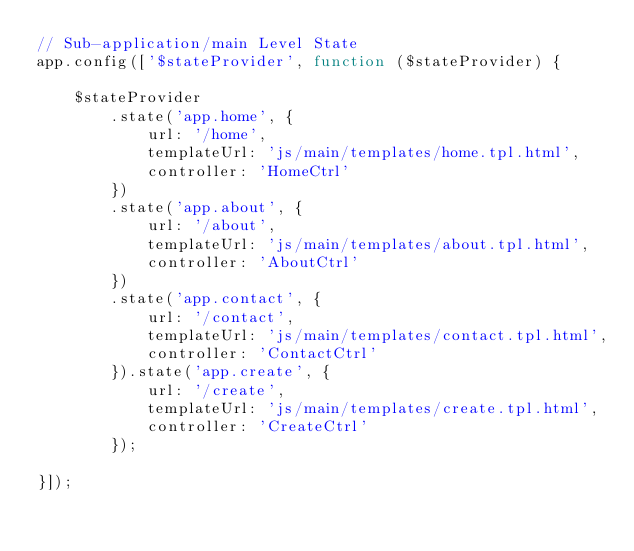Convert code to text. <code><loc_0><loc_0><loc_500><loc_500><_JavaScript_>// Sub-application/main Level State
app.config(['$stateProvider', function ($stateProvider) {

    $stateProvider
        .state('app.home', {
            url: '/home',
            templateUrl: 'js/main/templates/home.tpl.html',
            controller: 'HomeCtrl'
        })
        .state('app.about', {
            url: '/about',
            templateUrl: 'js/main/templates/about.tpl.html',
            controller: 'AboutCtrl'
        })
        .state('app.contact', {
            url: '/contact',
            templateUrl: 'js/main/templates/contact.tpl.html',
            controller: 'ContactCtrl'
        }).state('app.create', {
            url: '/create',
            templateUrl: 'js/main/templates/create.tpl.html',
            controller: 'CreateCtrl'
        });

}]);</code> 